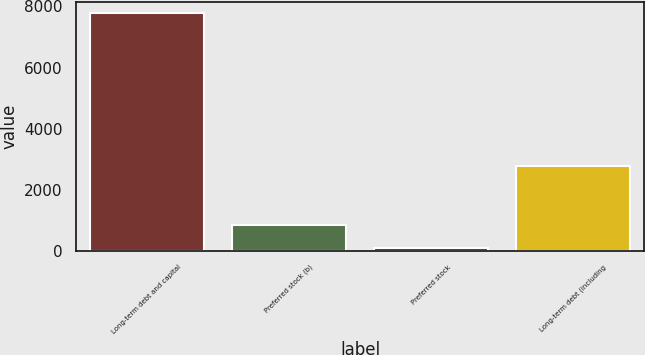Convert chart to OTSL. <chart><loc_0><loc_0><loc_500><loc_500><bar_chart><fcel>Long-term debt and capital<fcel>Preferred stock (b)<fcel>Preferred stock<fcel>Long-term debt (including<nl><fcel>7772<fcel>848.3<fcel>79<fcel>2765<nl></chart> 